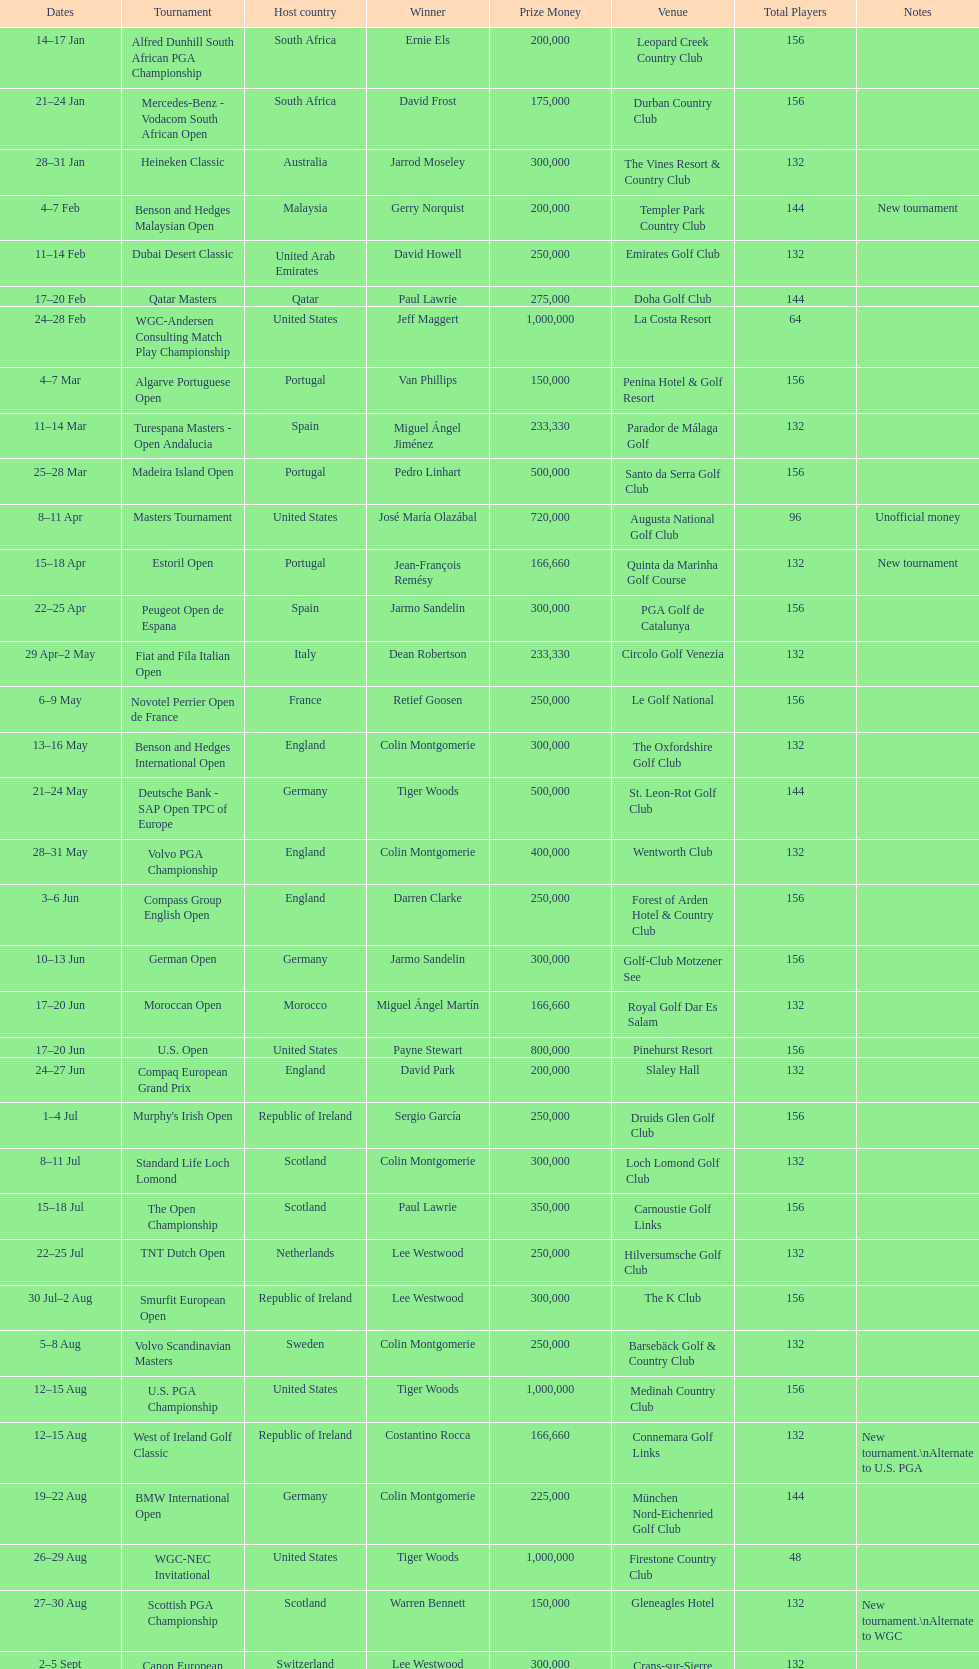How many successive times was south africa the host nation? 2. 